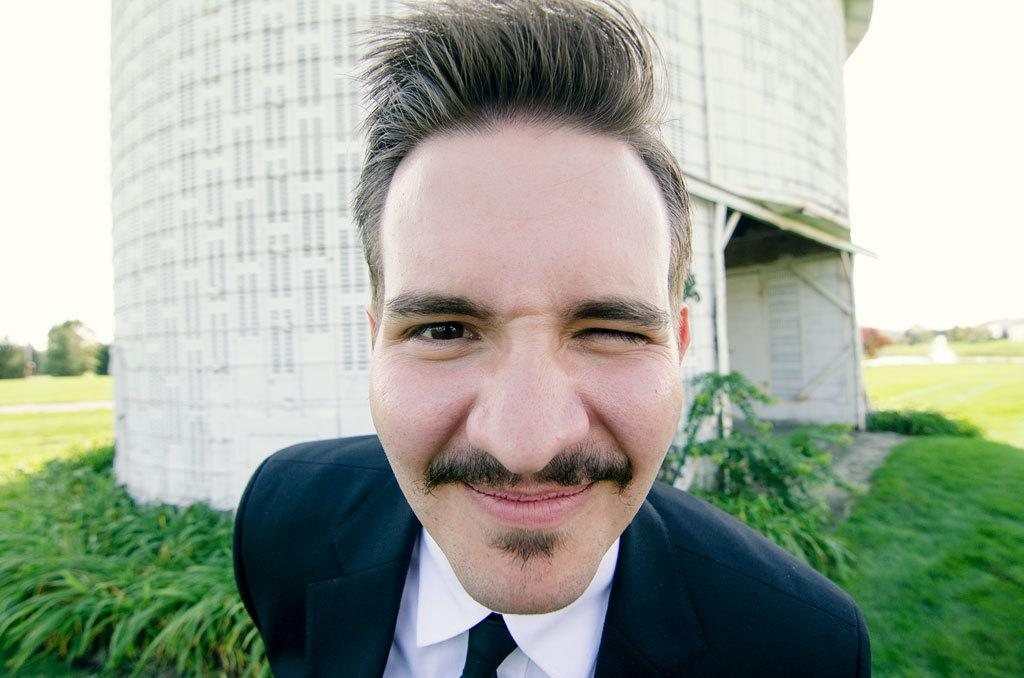Who is present in the image? There is a man in the image. What is the man wearing? The man is wearing a black jacket, white shirt, and tie. What can be seen in the background of the image? There is a tower in the background of the image. What type of terrain is visible in the image? There is grass on the ground in the image. How many lizards can be seen crawling on the grass in the image? There are no lizards present in the image; it only features a man and a tower in the background. What type of tool is being used to rake the grass in the image? There is no tool or activity related to raking the grass in the image. 